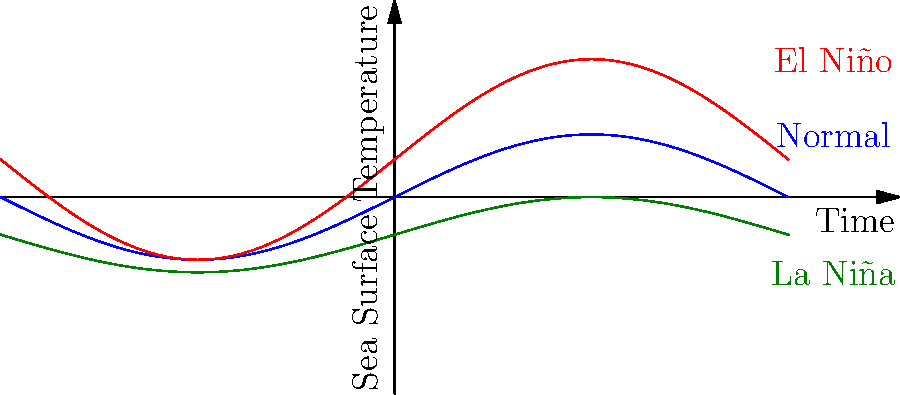Based on the graph showing sea surface temperature patterns over time, which phenomenon is characterized by the highest positive temperature anomalies in the Pacific Ocean? To answer this question, let's analyze the graph step-by-step:

1. The graph shows three different curves representing sea surface temperature patterns over time:
   - A blue curve labeled "Normal"
   - A red curve labeled "El Niño"
   - A green curve labeled "La Niña"

2. The y-axis represents sea surface temperature, with higher values indicating warmer temperatures.

3. Comparing the three curves:
   - The blue "Normal" curve oscillates around the middle of the graph, representing average conditions.
   - The red "El Niño" curve is consistently above the normal curve, showing higher temperatures.
   - The green "La Niña" curve is consistently below the normal curve, showing lower temperatures.

4. The El Niño curve (red) reaches the highest points on the graph, indicating the warmest sea surface temperatures.

5. In climatology, El Niño is indeed characterized by abnormally warm ocean temperatures in the equatorial Pacific, which is accurately represented by the red curve in this graph.

Therefore, El Niño is the phenomenon characterized by the highest positive temperature anomalies in the Pacific Ocean.
Answer: El Niño 